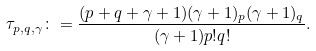<formula> <loc_0><loc_0><loc_500><loc_500>\tau _ { p , q , \gamma } \colon = \frac { ( p + q + \gamma + 1 ) ( \gamma + 1 ) _ { p } ( \gamma + 1 ) _ { q } } { ( \gamma + 1 ) p ! q ! } .</formula> 